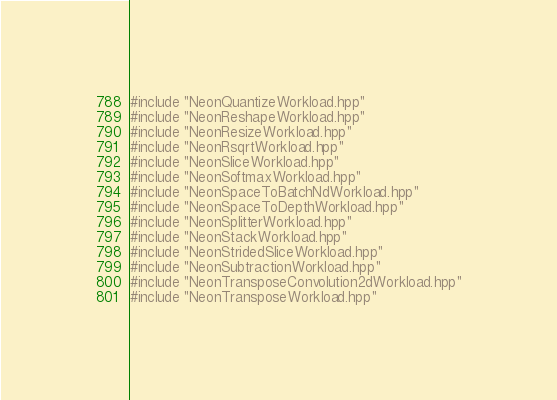Convert code to text. <code><loc_0><loc_0><loc_500><loc_500><_C++_>#include "NeonQuantizeWorkload.hpp"
#include "NeonReshapeWorkload.hpp"
#include "NeonResizeWorkload.hpp"
#include "NeonRsqrtWorkload.hpp"
#include "NeonSliceWorkload.hpp"
#include "NeonSoftmaxWorkload.hpp"
#include "NeonSpaceToBatchNdWorkload.hpp"
#include "NeonSpaceToDepthWorkload.hpp"
#include "NeonSplitterWorkload.hpp"
#include "NeonStackWorkload.hpp"
#include "NeonStridedSliceWorkload.hpp"
#include "NeonSubtractionWorkload.hpp"
#include "NeonTransposeConvolution2dWorkload.hpp"
#include "NeonTransposeWorkload.hpp"
</code> 